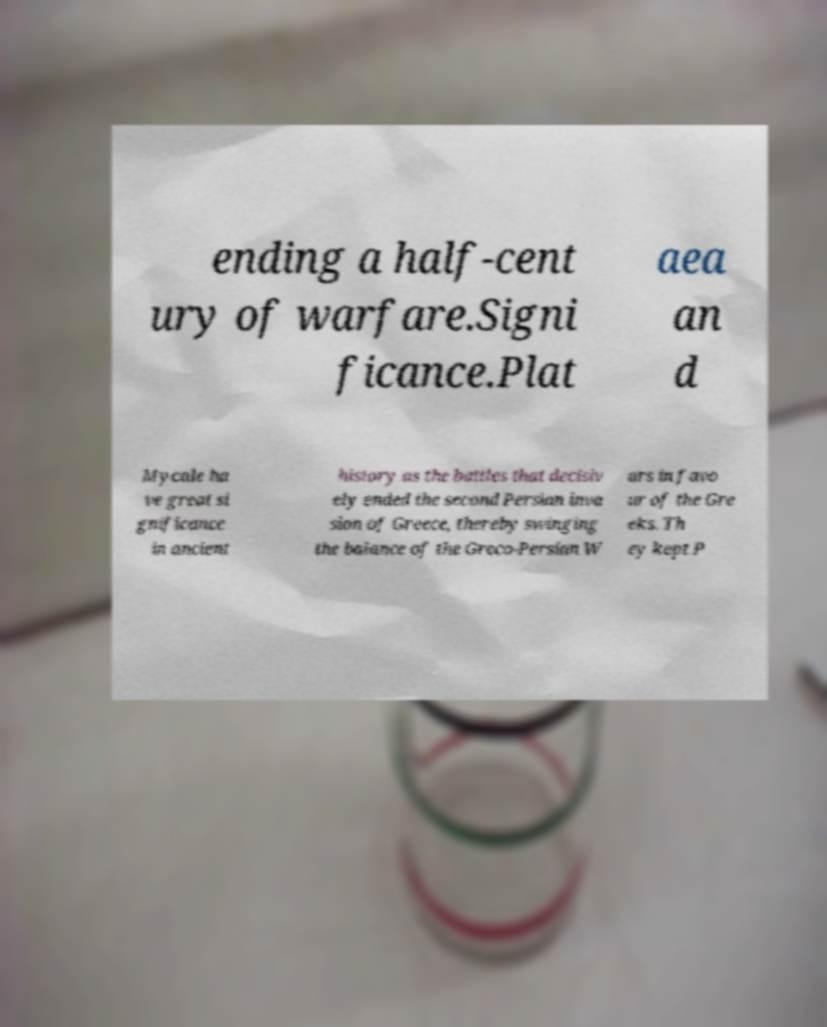For documentation purposes, I need the text within this image transcribed. Could you provide that? ending a half-cent ury of warfare.Signi ficance.Plat aea an d Mycale ha ve great si gnificance in ancient history as the battles that decisiv ely ended the second Persian inva sion of Greece, thereby swinging the balance of the Greco-Persian W ars in favo ur of the Gre eks. Th ey kept P 